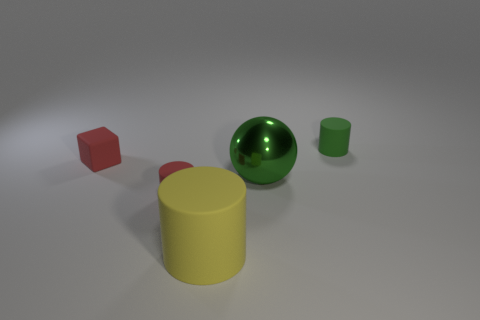Add 4 big rubber cubes. How many objects exist? 9 Subtract all blocks. How many objects are left? 4 Subtract all gray metal things. Subtract all tiny red cylinders. How many objects are left? 4 Add 4 red rubber blocks. How many red rubber blocks are left? 5 Add 2 yellow cylinders. How many yellow cylinders exist? 3 Subtract 1 green cylinders. How many objects are left? 4 